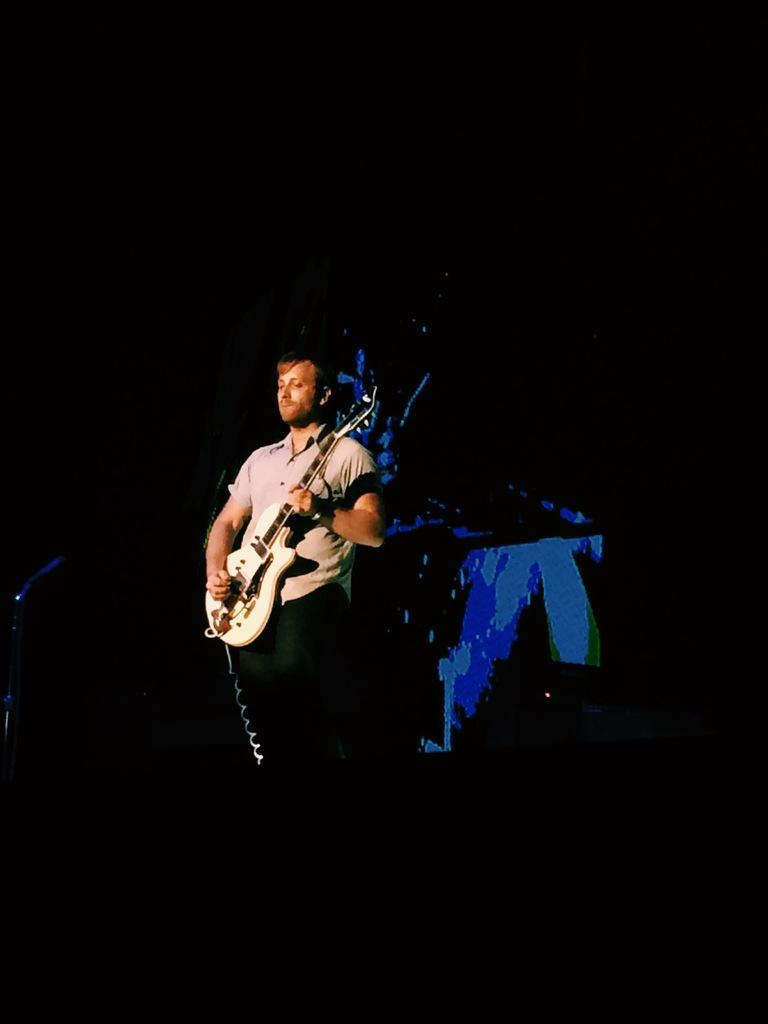Describe this image in one or two sentences. In this picture we can see a man is standing and playing guitar, there is a dark background. 